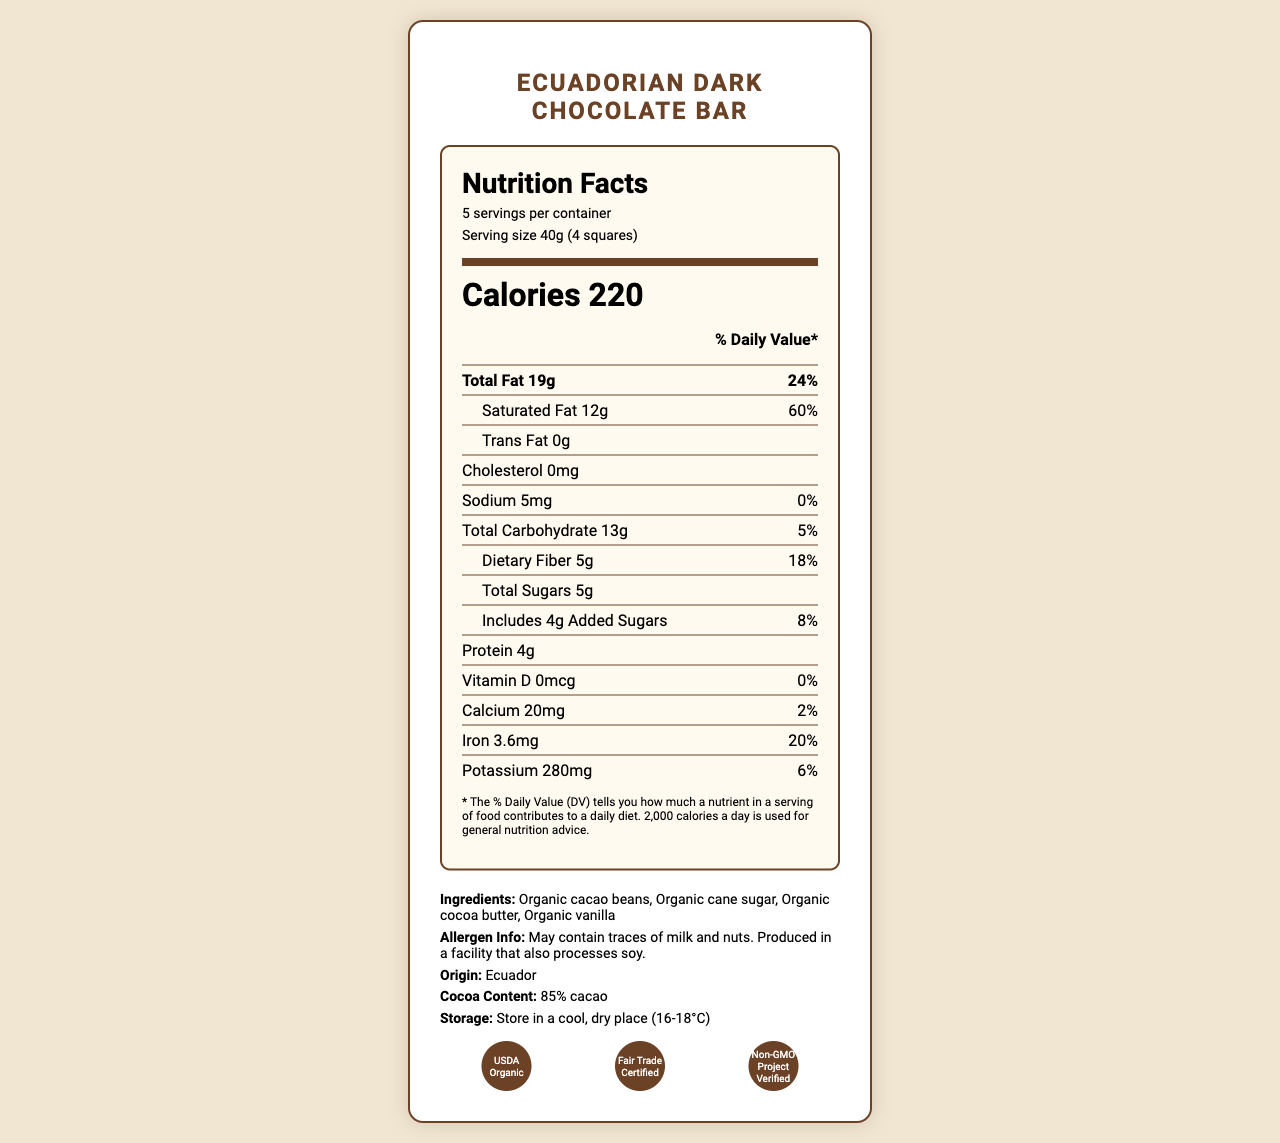what is the serving size of the product? The serving size is explicitly mentioned as "40g (4 squares)" in the document.
Answer: 40g (4 squares) how many calories are there per serving? The calorie content per serving is listed as 220.
Answer: 220 what country is the chocolate bar from? The document states the country of origin is Ecuador.
Answer: Ecuador how much protein does each serving contain? The document specifies that each serving contains 4g of protein.
Answer: 4g what is the daily value percentage of iron in one serving? The daily value percentage for iron per serving is noted as 20%.
Answer: 20% is the product allergen-free? The document states that while it is made with organic ingredients, it "May contain traces of milk and nuts" and is produced in a facility that also processes soy.
Answer: No summarize the main information provided about the product in the document. The document gives a detailed overview of the chocolate bar’s nutritional content, certifications, ingredients, allergen information, and origin.
Answer: The Ecuadorian Dark Chocolate Bar produced by Pacari Chocolate from Ecuador has 85% cocoa content. It provides detailed nutritional information including serving size, calories, fats, sugars, and various vitamins and minerals. The product is certified organic, fair trade, and non-GMO. Allergen information, storage instructions, and import details are also provided. what is the production date of the chocolate bar? The document does not provide the production date directly; it only mentions the best-before date is 18 months from the production date.
Answer: Not enough information what is the amount of dietary fiber in each serving? The document specifies that each serving contains 5g of dietary fiber.
Answer: 5g what is the expiration period of the chocolate bar? The document mentions that the best-before date is "18 months from production date."
Answer: 18 months from production date how much calcium is in each serving? Each serving has 20mg of calcium, as specified in the nutritional details.
Answer: 20mg does the chocolate bar contain any trans fat? The document clearly states that the trans fat amount is "0g."
Answer: No 